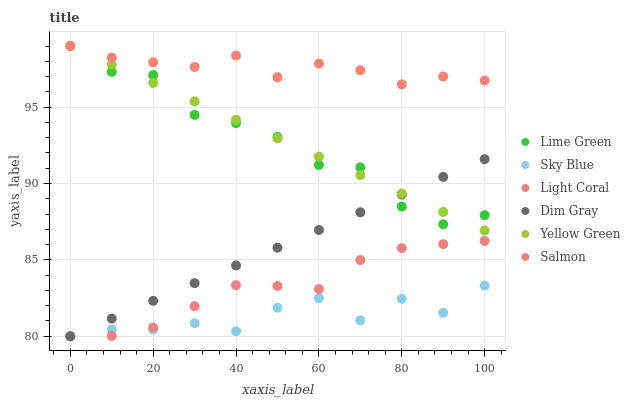Does Sky Blue have the minimum area under the curve?
Answer yes or no. Yes. Does Salmon have the maximum area under the curve?
Answer yes or no. Yes. Does Yellow Green have the minimum area under the curve?
Answer yes or no. No. Does Yellow Green have the maximum area under the curve?
Answer yes or no. No. Is Dim Gray the smoothest?
Answer yes or no. Yes. Is Sky Blue the roughest?
Answer yes or no. Yes. Is Yellow Green the smoothest?
Answer yes or no. No. Is Yellow Green the roughest?
Answer yes or no. No. Does Dim Gray have the lowest value?
Answer yes or no. Yes. Does Yellow Green have the lowest value?
Answer yes or no. No. Does Lime Green have the highest value?
Answer yes or no. Yes. Does Light Coral have the highest value?
Answer yes or no. No. Is Dim Gray less than Salmon?
Answer yes or no. Yes. Is Salmon greater than Light Coral?
Answer yes or no. Yes. Does Dim Gray intersect Sky Blue?
Answer yes or no. Yes. Is Dim Gray less than Sky Blue?
Answer yes or no. No. Is Dim Gray greater than Sky Blue?
Answer yes or no. No. Does Dim Gray intersect Salmon?
Answer yes or no. No. 